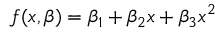<formula> <loc_0><loc_0><loc_500><loc_500>f ( x , { \beta } ) = \beta _ { 1 } + \beta _ { 2 } x + \beta _ { 3 } x ^ { 2 }</formula> 